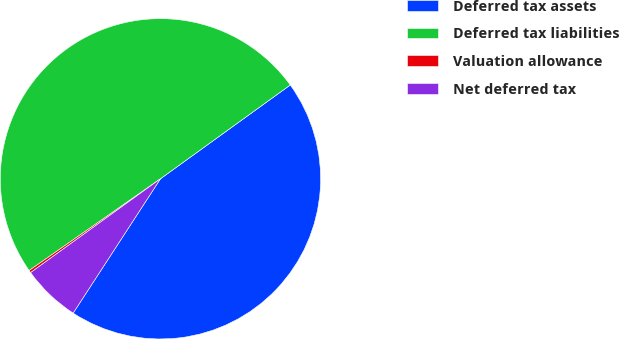Convert chart. <chart><loc_0><loc_0><loc_500><loc_500><pie_chart><fcel>Deferred tax assets<fcel>Deferred tax liabilities<fcel>Valuation allowance<fcel>Net deferred tax<nl><fcel>44.13%<fcel>49.75%<fcel>0.25%<fcel>5.87%<nl></chart> 